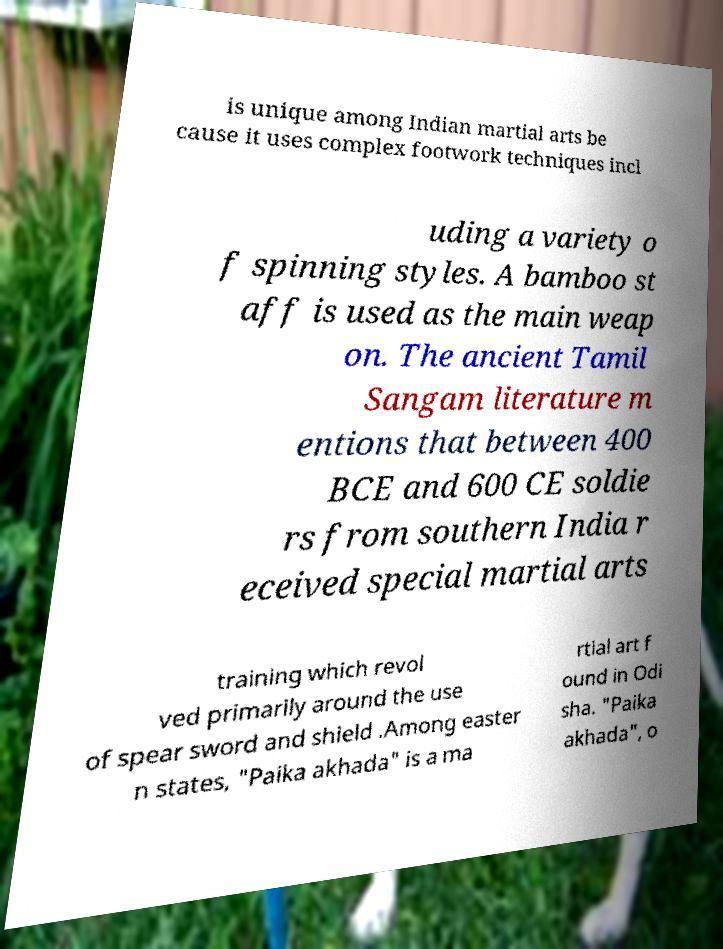What messages or text are displayed in this image? I need them in a readable, typed format. is unique among Indian martial arts be cause it uses complex footwork techniques incl uding a variety o f spinning styles. A bamboo st aff is used as the main weap on. The ancient Tamil Sangam literature m entions that between 400 BCE and 600 CE soldie rs from southern India r eceived special martial arts training which revol ved primarily around the use of spear sword and shield .Among easter n states, "Paika akhada" is a ma rtial art f ound in Odi sha. "Paika akhada", o 